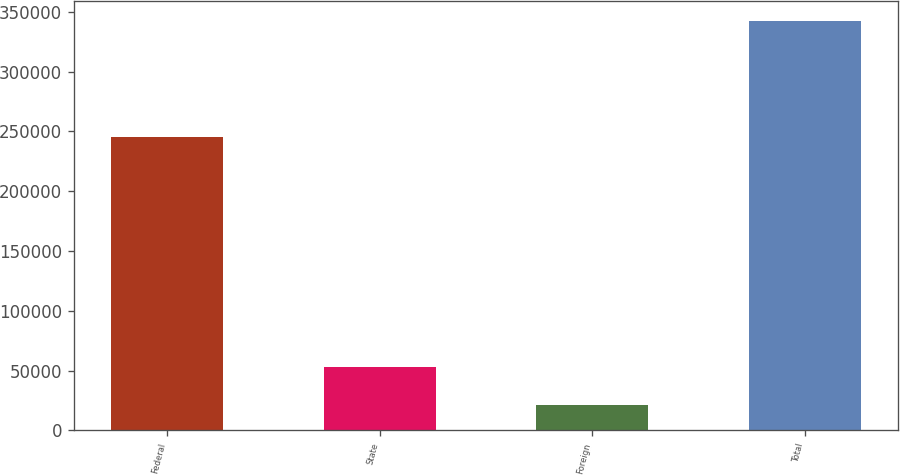Convert chart to OTSL. <chart><loc_0><loc_0><loc_500><loc_500><bar_chart><fcel>Federal<fcel>State<fcel>Foreign<fcel>Total<nl><fcel>245189<fcel>53232.2<fcel>21138<fcel>342080<nl></chart> 